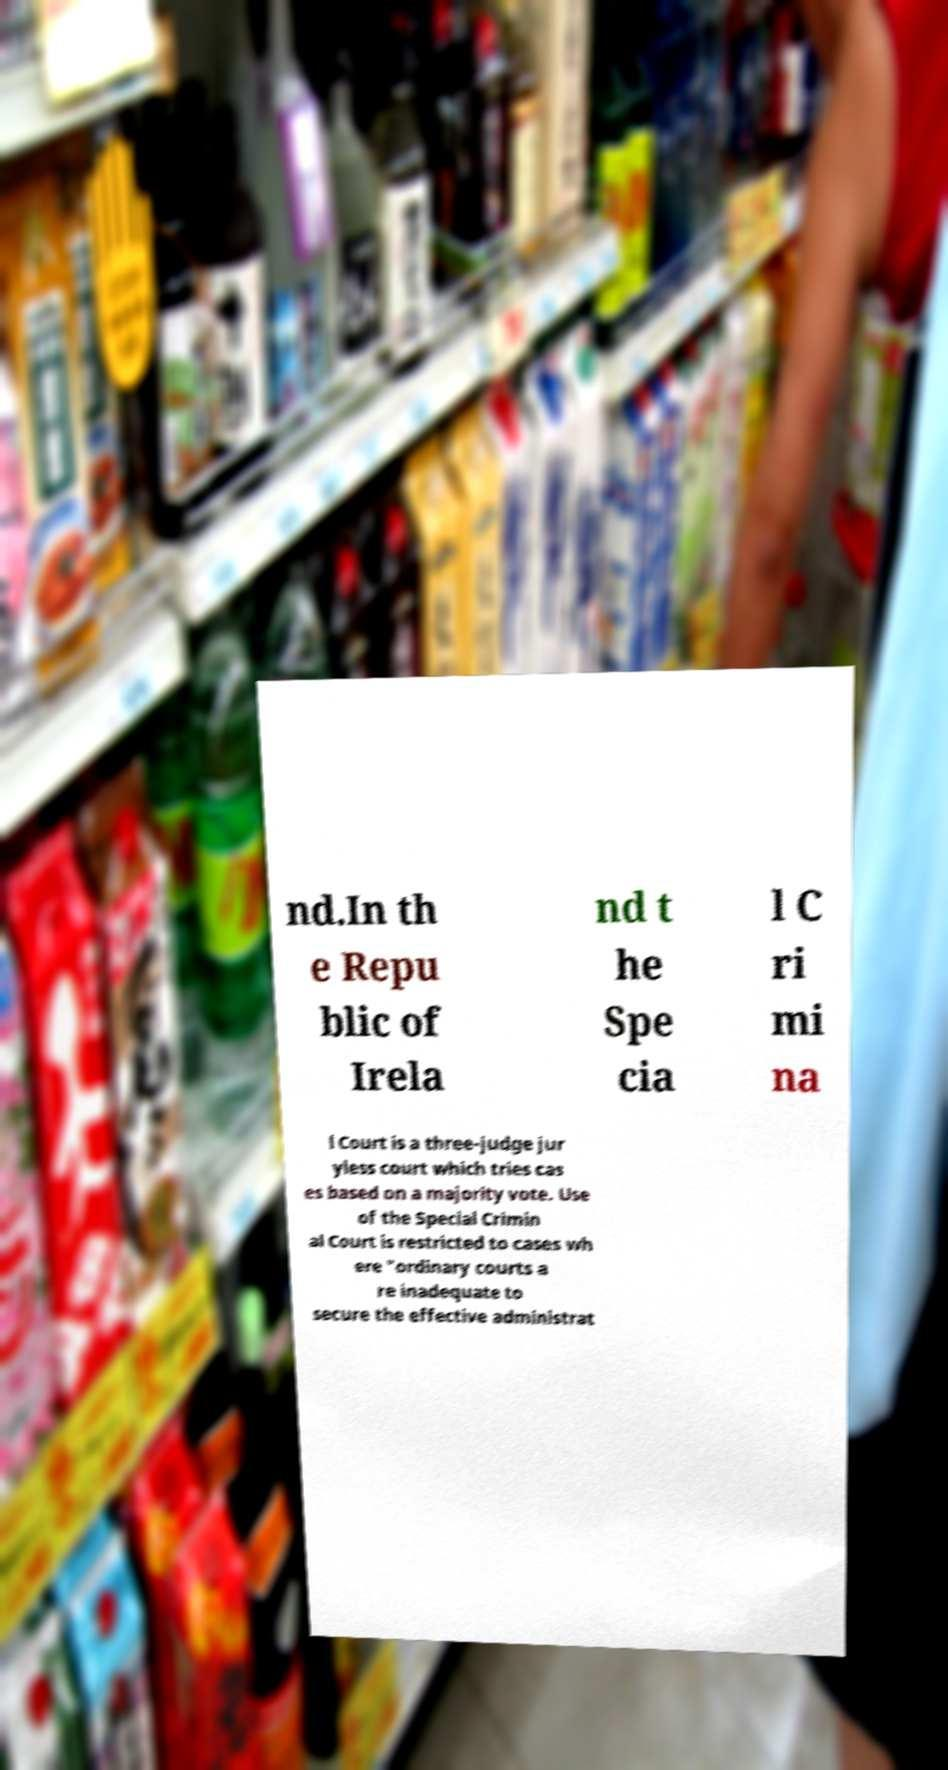What messages or text are displayed in this image? I need them in a readable, typed format. nd.In th e Repu blic of Irela nd t he Spe cia l C ri mi na l Court is a three-judge jur yless court which tries cas es based on a majority vote. Use of the Special Crimin al Court is restricted to cases wh ere "ordinary courts a re inadequate to secure the effective administrat 